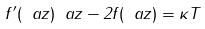<formula> <loc_0><loc_0><loc_500><loc_500>f ^ { \prime } ( \ a z ) \ a z - 2 f ( \ a z ) = \kappa T</formula> 